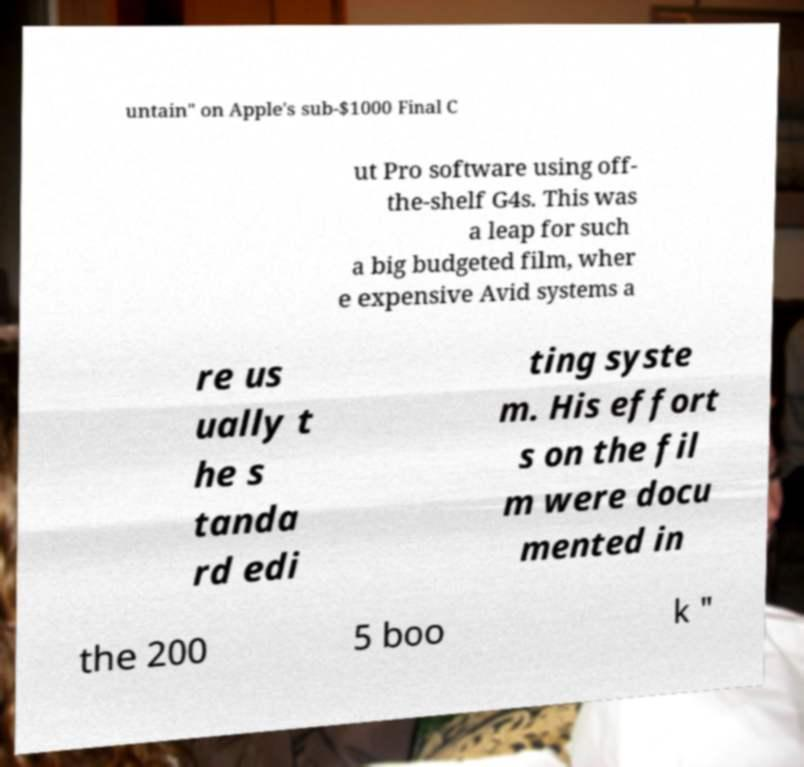What messages or text are displayed in this image? I need them in a readable, typed format. untain" on Apple's sub-$1000 Final C ut Pro software using off- the-shelf G4s. This was a leap for such a big budgeted film, wher e expensive Avid systems a re us ually t he s tanda rd edi ting syste m. His effort s on the fil m were docu mented in the 200 5 boo k " 